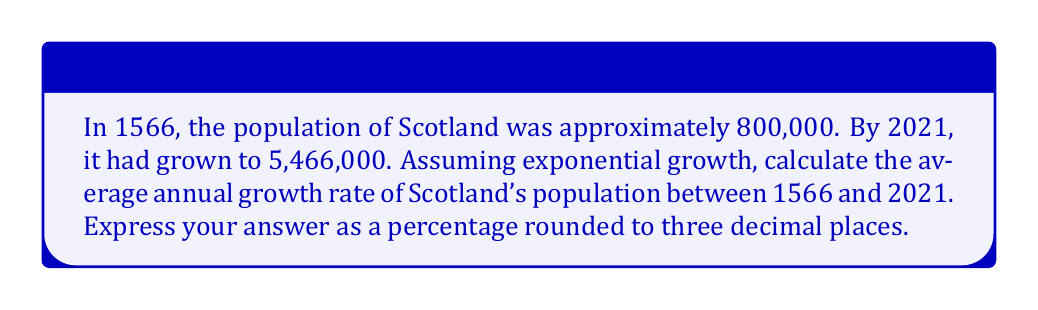Give your solution to this math problem. To solve this problem, we'll use the exponential growth formula:

$$ P(t) = P_0 \cdot e^{rt} $$

Where:
$P(t)$ is the final population
$P_0$ is the initial population
$r$ is the annual growth rate
$t$ is the time in years

1. Identify the known values:
   $P_0 = 800,000$ (population in 1566)
   $P(t) = 5,466,000$ (population in 2021)
   $t = 2021 - 1566 = 455$ years

2. Substitute these values into the formula:
   $$ 5,466,000 = 800,000 \cdot e^{455r} $$

3. Divide both sides by 800,000:
   $$ \frac{5,466,000}{800,000} = e^{455r} $$

4. Take the natural logarithm of both sides:
   $$ \ln\left(\frac{5,466,000}{800,000}\right) = 455r $$

5. Solve for $r$:
   $$ r = \frac{\ln\left(\frac{5,466,000}{800,000}\right)}{455} $$

6. Calculate the value of $r$:
   $$ r = \frac{\ln(6.8325)}{455} \approx 0.004212 $$

7. Convert to a percentage and round to three decimal places:
   $0.004212 \times 100 \approx 0.421\%$
Answer: 0.421% 